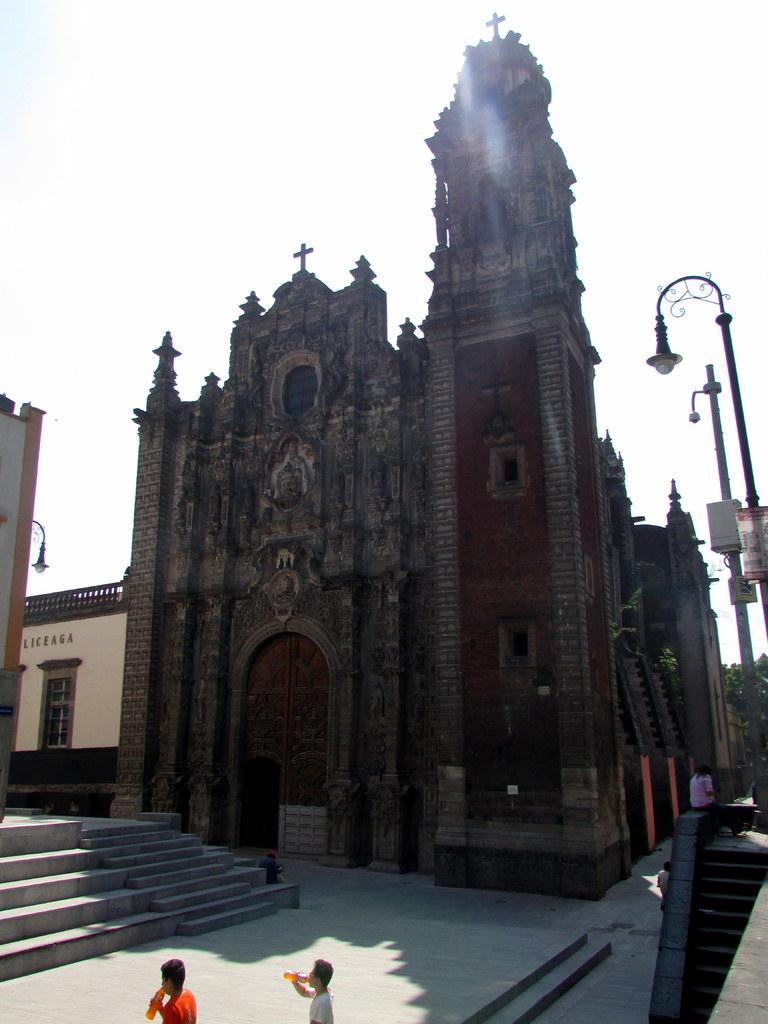How would you summarize this image in a sentence or two? This picture is clicked outside. In the foreground we can see the two persons and we can see the stairs. In the center there is a building and a spire and we can see the buildings, lights attached to the poles. In the background there is a sky. 